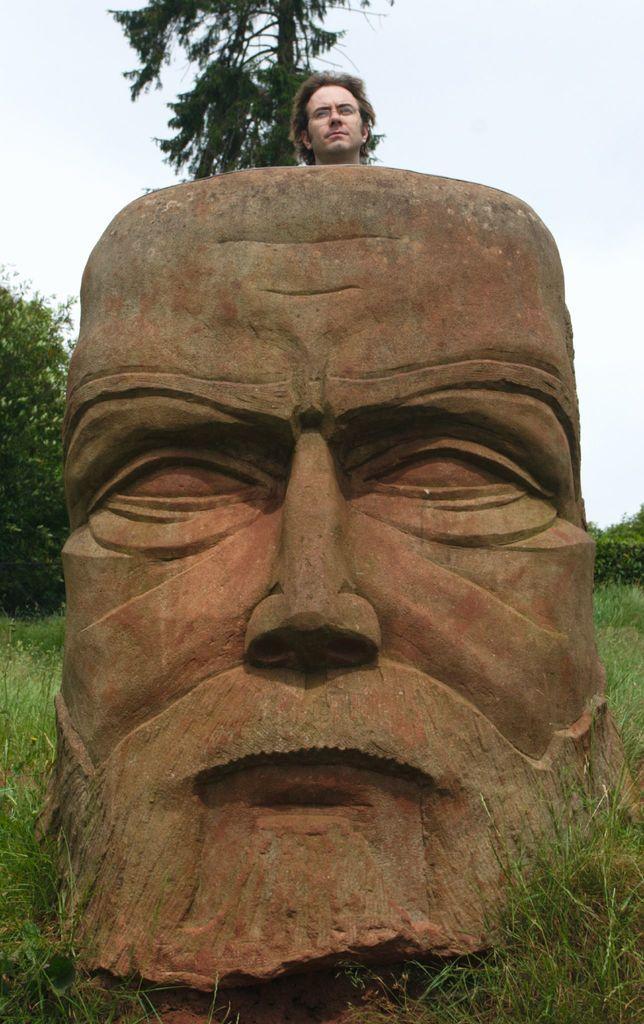Can you describe this image briefly? In the image there is a man standing behind a statue of a face, in the back there are trees on the grassland and above its sky. 